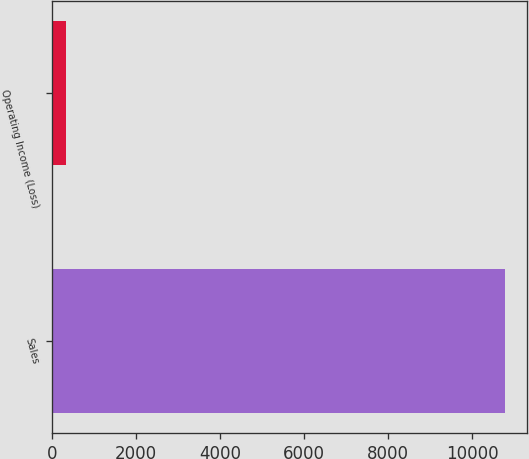Convert chart to OTSL. <chart><loc_0><loc_0><loc_500><loc_500><bar_chart><fcel>Sales<fcel>Operating Income (Loss)<nl><fcel>10782<fcel>346<nl></chart> 